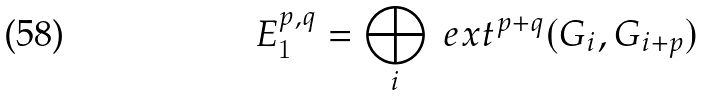<formula> <loc_0><loc_0><loc_500><loc_500>E _ { 1 } ^ { p , q } = \bigoplus _ { i } \ e x t ^ { p + q } ( G _ { i } , G _ { i + p } )</formula> 